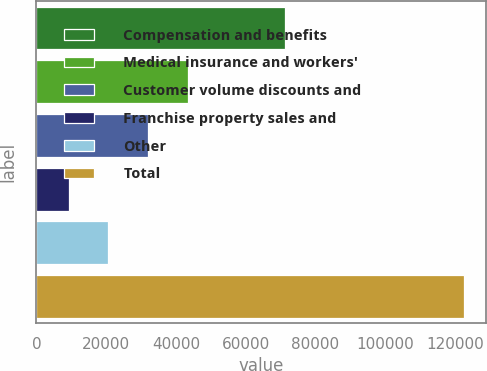<chart> <loc_0><loc_0><loc_500><loc_500><bar_chart><fcel>Compensation and benefits<fcel>Medical insurance and workers'<fcel>Customer volume discounts and<fcel>Franchise property sales and<fcel>Other<fcel>Total<nl><fcel>71246<fcel>43344.7<fcel>32008.8<fcel>9337<fcel>20672.9<fcel>122696<nl></chart> 